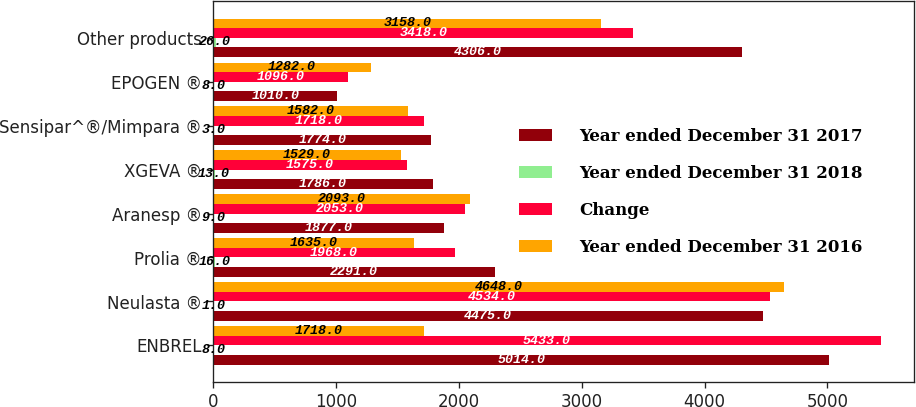Convert chart. <chart><loc_0><loc_0><loc_500><loc_500><stacked_bar_chart><ecel><fcel>ENBREL<fcel>Neulasta ®<fcel>Prolia ®<fcel>Aranesp ®<fcel>XGEVA ®<fcel>Sensipar^®/Mimpara ®<fcel>EPOGEN ®<fcel>Other products<nl><fcel>Year ended December 31 2017<fcel>5014<fcel>4475<fcel>2291<fcel>1877<fcel>1786<fcel>1774<fcel>1010<fcel>4306<nl><fcel>Year ended December 31 2018<fcel>8<fcel>1<fcel>16<fcel>9<fcel>13<fcel>3<fcel>8<fcel>26<nl><fcel>Change<fcel>5433<fcel>4534<fcel>1968<fcel>2053<fcel>1575<fcel>1718<fcel>1096<fcel>3418<nl><fcel>Year ended December 31 2016<fcel>1718<fcel>4648<fcel>1635<fcel>2093<fcel>1529<fcel>1582<fcel>1282<fcel>3158<nl></chart> 